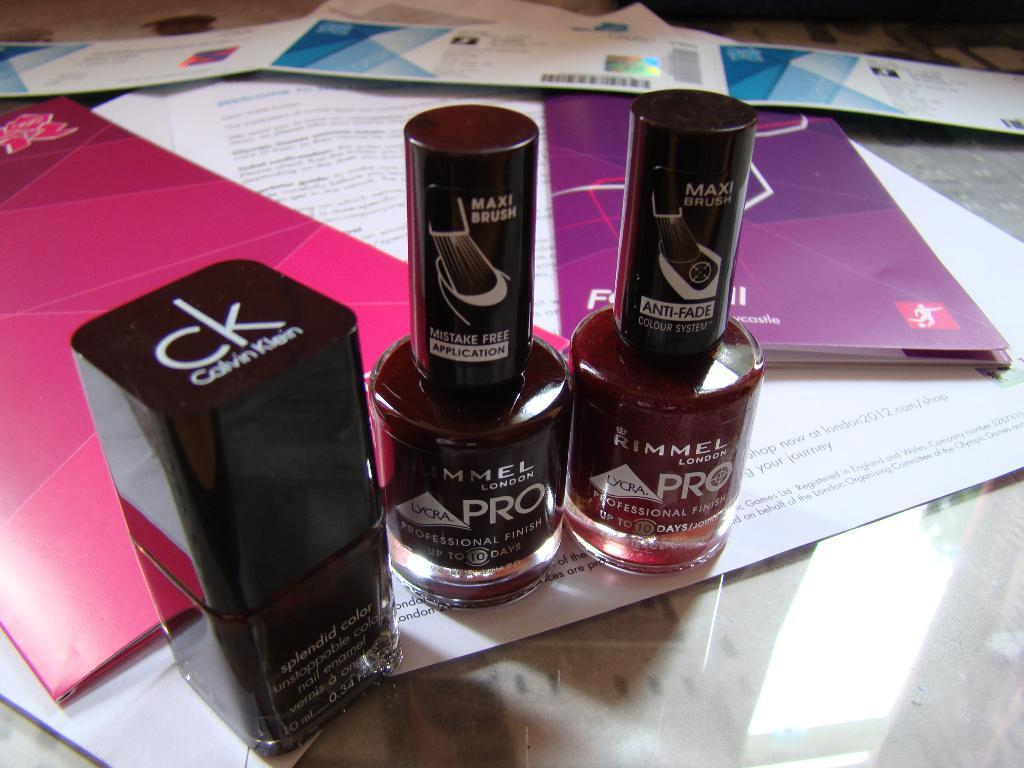Provide a one-sentence caption for the provided image. a couple of bottles with the word pro on both of them. 